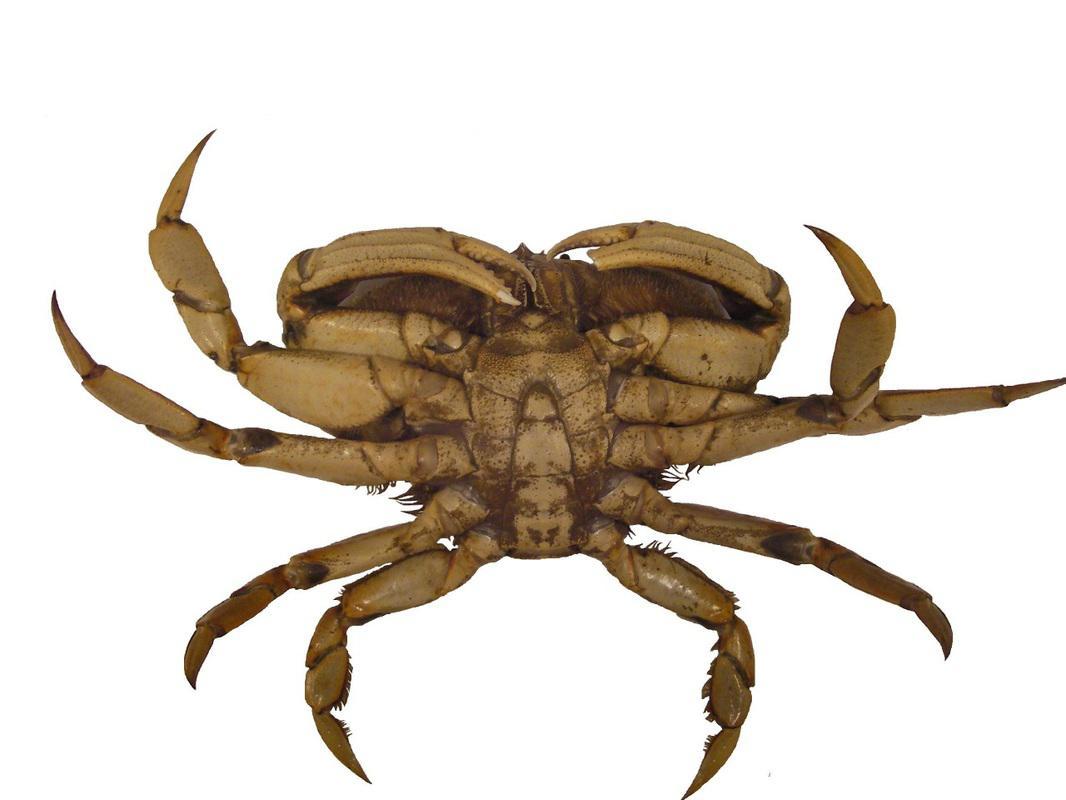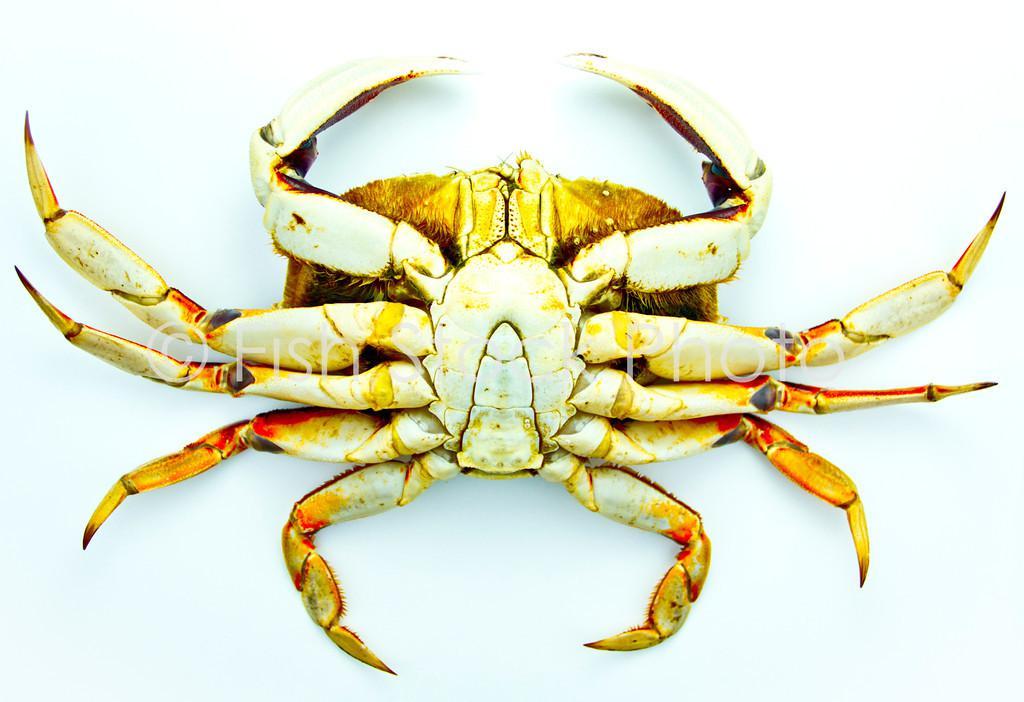The first image is the image on the left, the second image is the image on the right. Assess this claim about the two images: "Both pictures show the underside of one crab and all are positioned in the same way.". Correct or not? Answer yes or no. Yes. The first image is the image on the left, the second image is the image on the right. Given the left and right images, does the statement "Each image is a bottom view of a single crab with its head at the top of the image and its front claws pointed toward each other." hold true? Answer yes or no. Yes. 